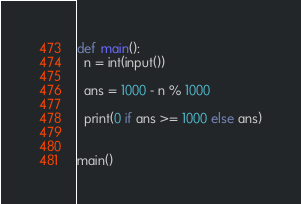<code> <loc_0><loc_0><loc_500><loc_500><_Python_>
def main():
  n = int(input())

  ans = 1000 - n % 1000

  print(0 if ans >= 1000 else ans)


main()
</code> 